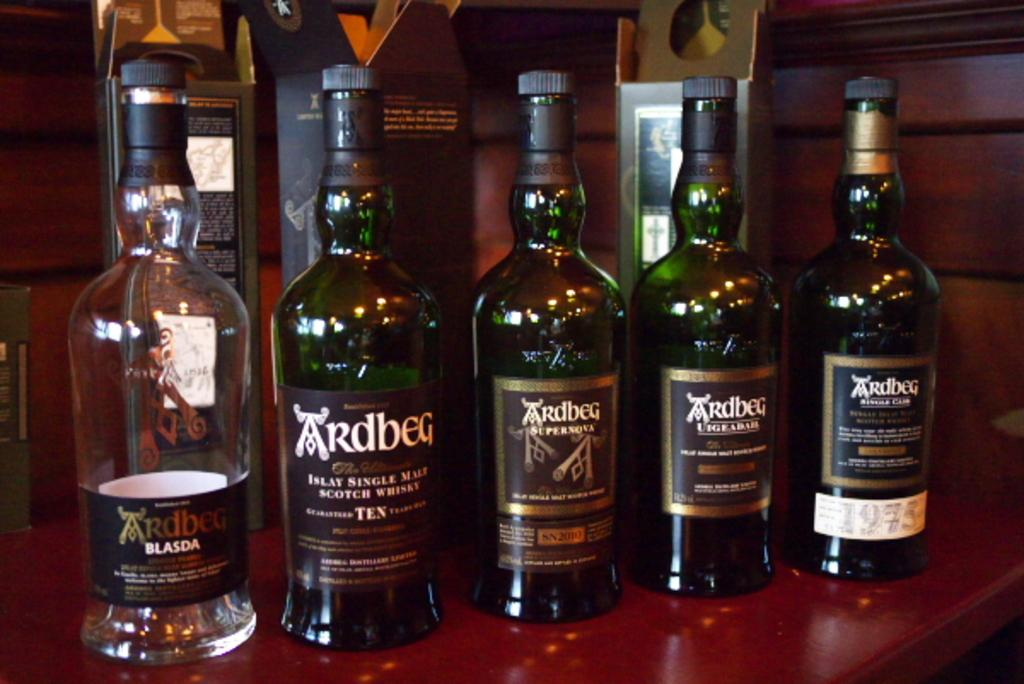Provide a one-sentence caption for the provided image. A bottle of single malt scotch whisky sits with other bottles on the bar. 